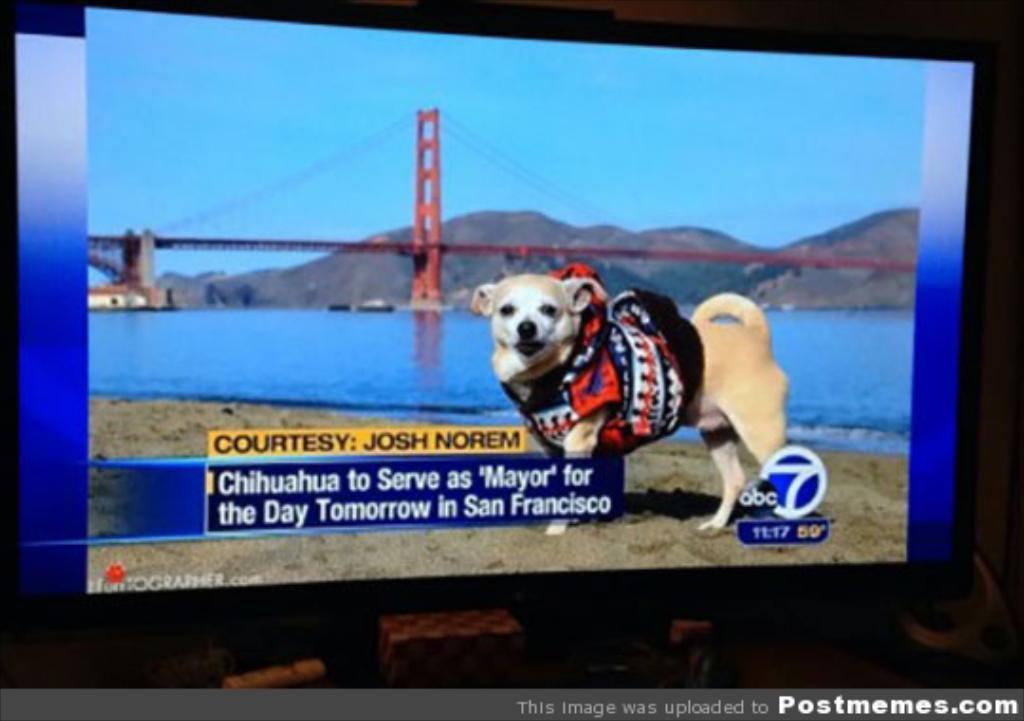Please provide a concise description of this image. In this image we can see a display screen. On the display screen there are the pictures of dog standing on the ground, river, bridge, hills and sky. 